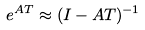<formula> <loc_0><loc_0><loc_500><loc_500>e ^ { A T } \approx ( I - A T ) ^ { - 1 }</formula> 